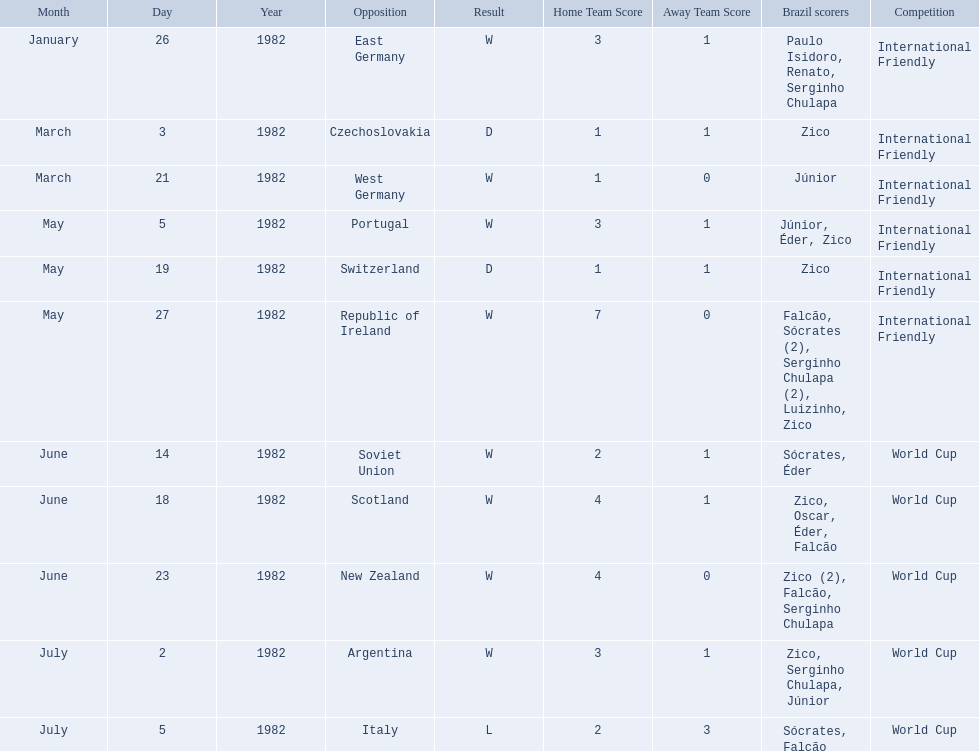What are all the dates of games in 1982 in brazilian football? January 26, 1982, March 3, 1982, March 21, 1982, May 5, 1982, May 19, 1982, May 27, 1982, June 14, 1982, June 18, 1982, June 23, 1982, July 2, 1982, July 5, 1982. Which of these dates is at the top of the chart? January 26, 1982. 